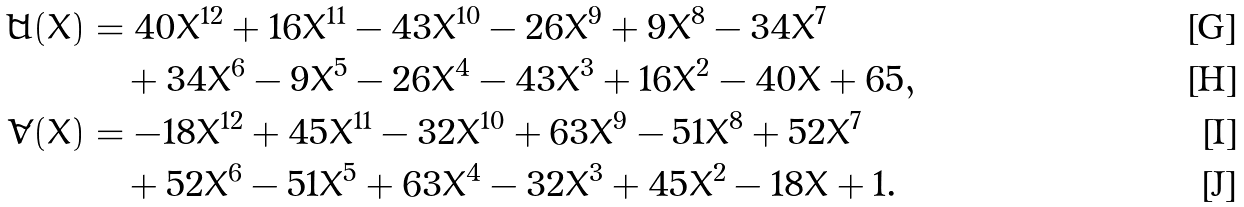Convert formula to latex. <formula><loc_0><loc_0><loc_500><loc_500>\tilde { U } ( X ) & = 4 0 X ^ { 1 2 } + 1 6 X ^ { 1 1 } - 4 3 X ^ { 1 0 } - 2 6 X ^ { 9 } + 9 X ^ { 8 } - 3 4 X ^ { 7 } \\ & \quad + 3 4 X ^ { 6 } - 9 X ^ { 5 } - 2 6 X ^ { 4 } - 4 3 X ^ { 3 } + 1 6 X ^ { 2 } - 4 0 X + 6 5 , \\ \tilde { V } ( X ) & = - 1 8 X ^ { 1 2 } + 4 5 X ^ { 1 1 } - 3 2 X ^ { 1 0 } + 6 3 X ^ { 9 } - 5 1 X ^ { 8 } + 5 2 X ^ { 7 } \\ & \quad + 5 2 X ^ { 6 } - 5 1 X ^ { 5 } + 6 3 X ^ { 4 } - 3 2 X ^ { 3 } + 4 5 X ^ { 2 } - 1 8 X + 1 .</formula> 